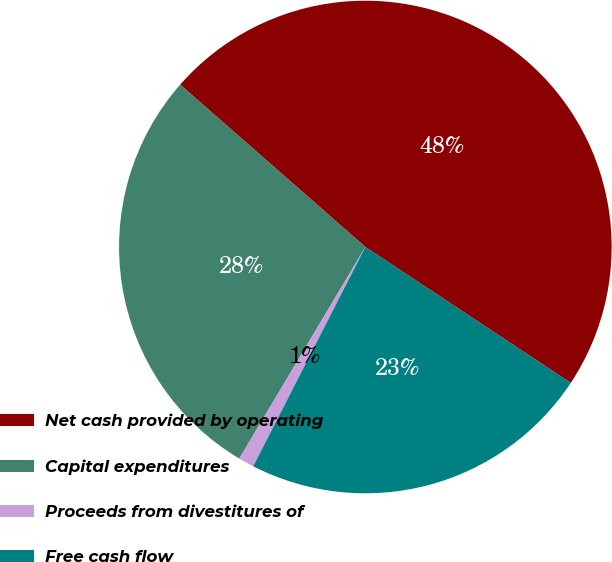Convert chart. <chart><loc_0><loc_0><loc_500><loc_500><pie_chart><fcel>Net cash provided by operating<fcel>Capital expenditures<fcel>Proceeds from divestitures of<fcel>Free cash flow<nl><fcel>47.85%<fcel>27.9%<fcel>1.03%<fcel>23.22%<nl></chart> 